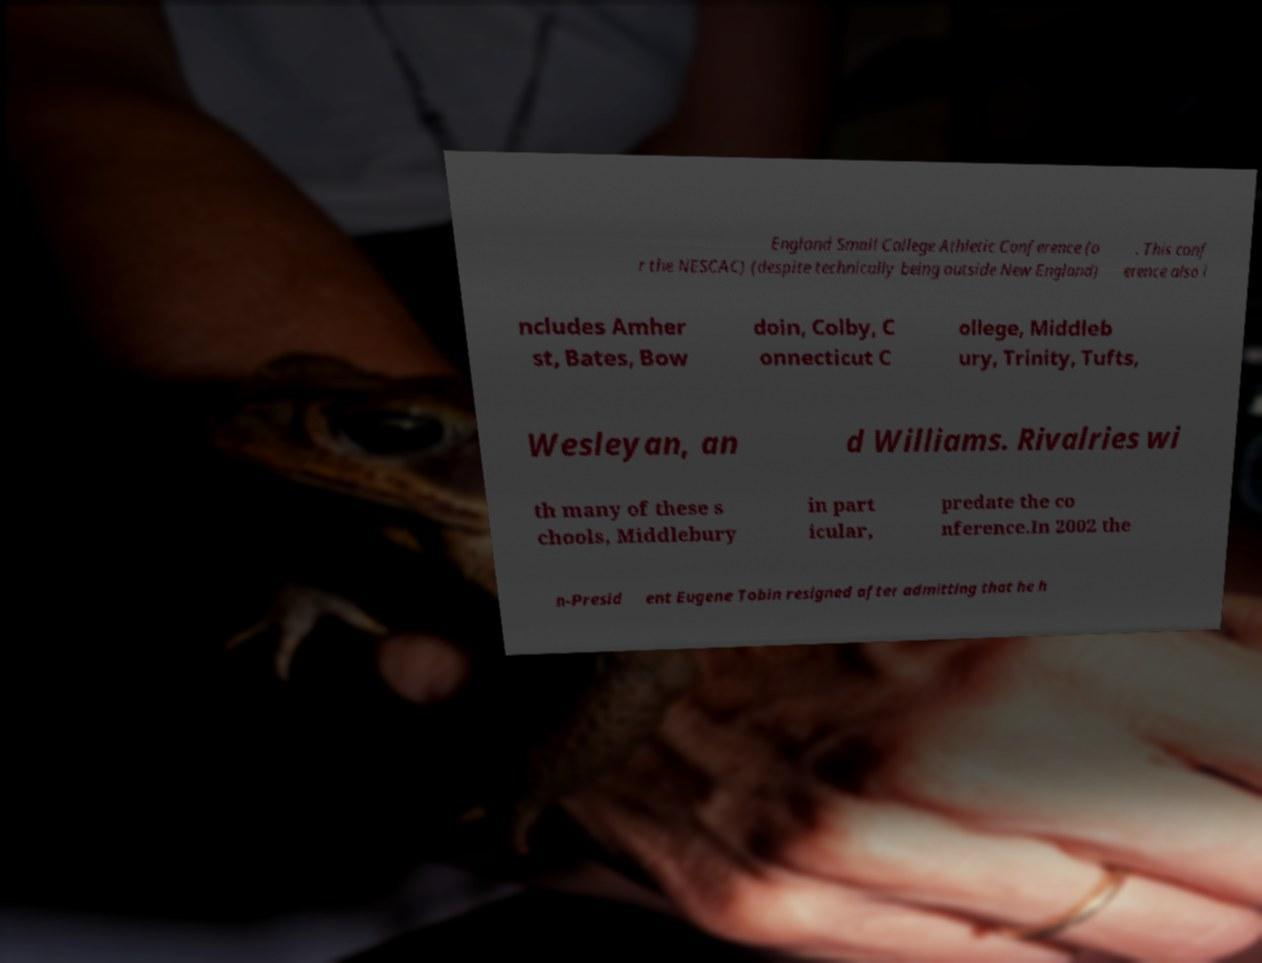Could you assist in decoding the text presented in this image and type it out clearly? England Small College Athletic Conference (o r the NESCAC) (despite technically being outside New England) . This conf erence also i ncludes Amher st, Bates, Bow doin, Colby, C onnecticut C ollege, Middleb ury, Trinity, Tufts, Wesleyan, an d Williams. Rivalries wi th many of these s chools, Middlebury in part icular, predate the co nference.In 2002 the n-Presid ent Eugene Tobin resigned after admitting that he h 